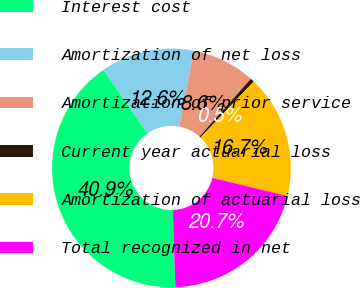Convert chart to OTSL. <chart><loc_0><loc_0><loc_500><loc_500><pie_chart><fcel>Interest cost<fcel>Amortization of net loss<fcel>Amortization of prior service<fcel>Current year actuarial loss<fcel>Amortization of actuarial loss<fcel>Total recognized in net<nl><fcel>40.89%<fcel>12.63%<fcel>8.59%<fcel>0.52%<fcel>16.67%<fcel>20.7%<nl></chart> 